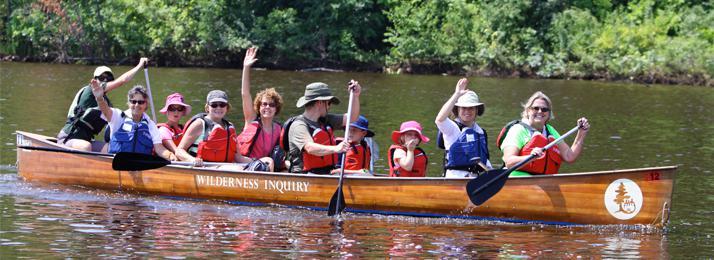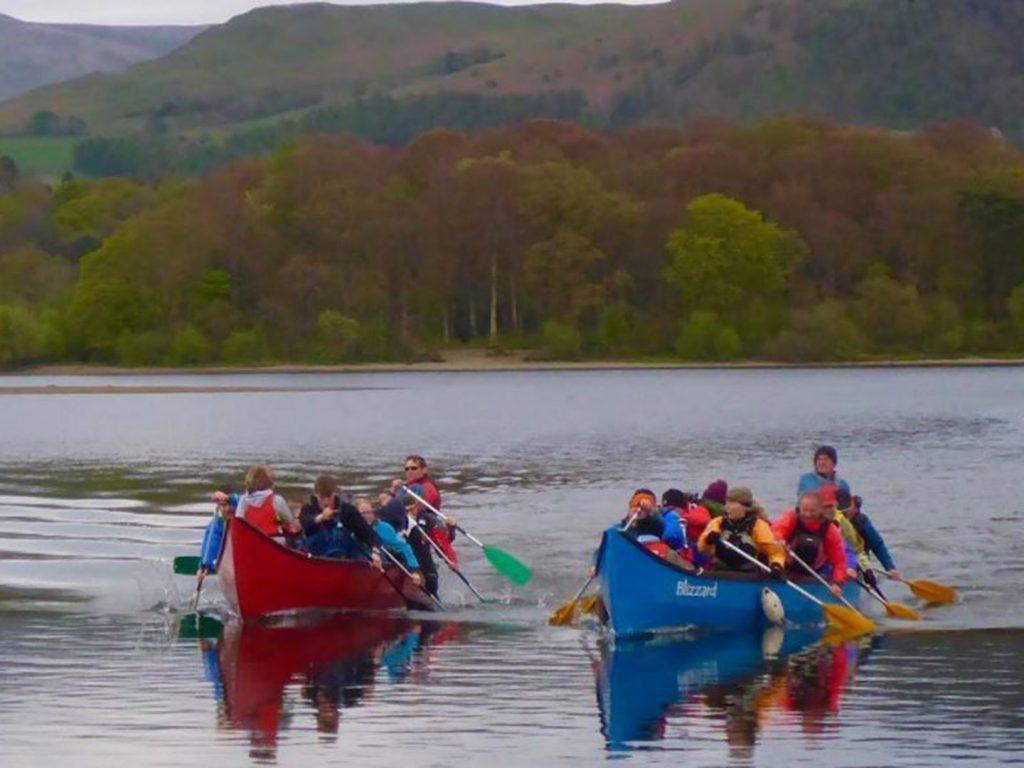The first image is the image on the left, the second image is the image on the right. Considering the images on both sides, is "The right image contains exactly two side-by-side canoes which are on the water and angled forward." valid? Answer yes or no. Yes. The first image is the image on the left, the second image is the image on the right. Given the left and right images, does the statement "There are exactly three canoes." hold true? Answer yes or no. Yes. 